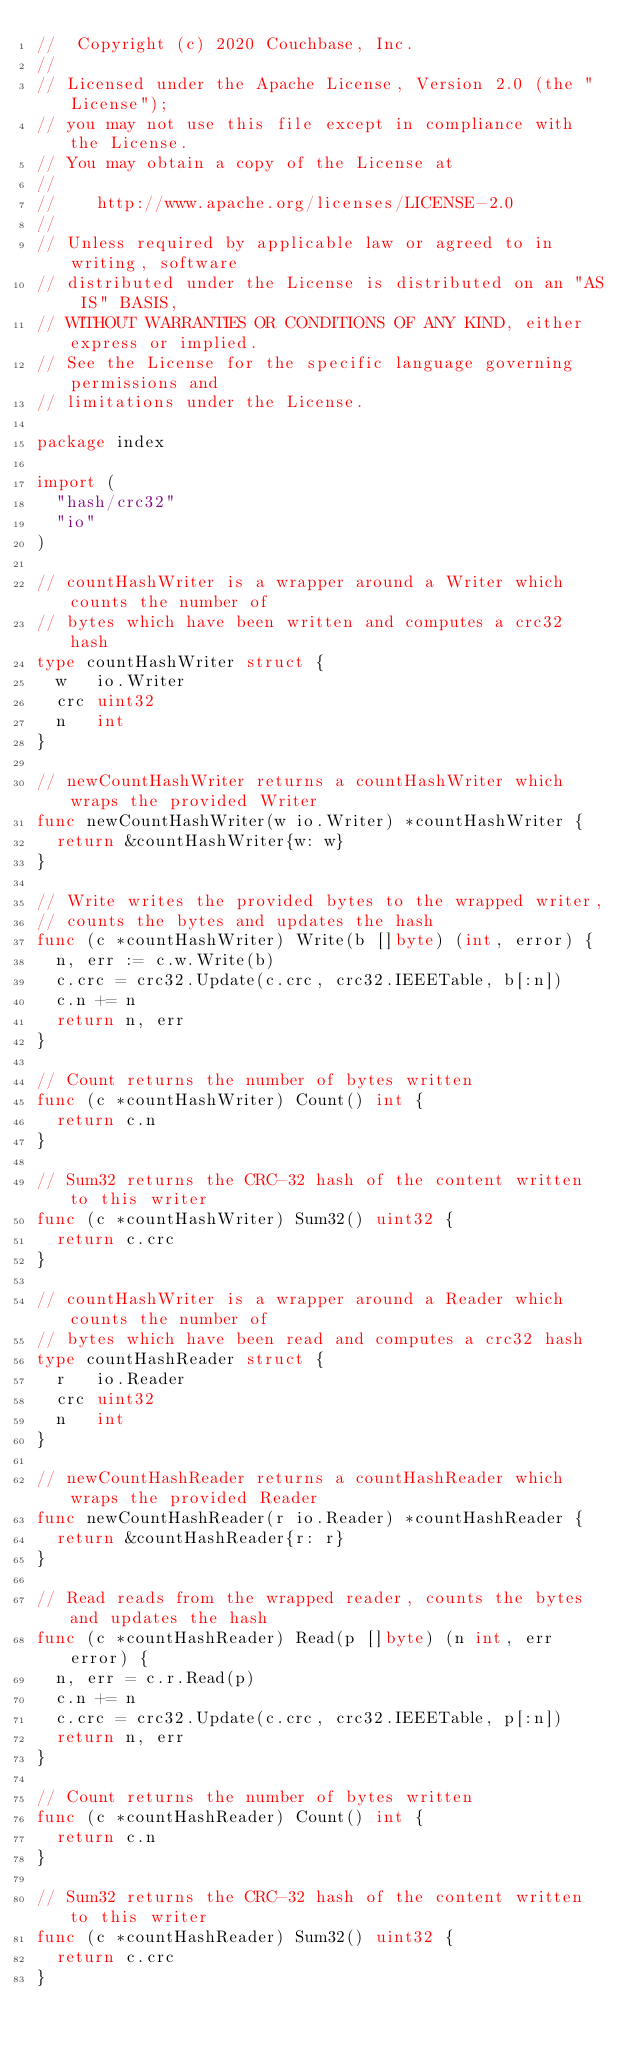<code> <loc_0><loc_0><loc_500><loc_500><_Go_>//  Copyright (c) 2020 Couchbase, Inc.
//
// Licensed under the Apache License, Version 2.0 (the "License");
// you may not use this file except in compliance with the License.
// You may obtain a copy of the License at
//
// 		http://www.apache.org/licenses/LICENSE-2.0
//
// Unless required by applicable law or agreed to in writing, software
// distributed under the License is distributed on an "AS IS" BASIS,
// WITHOUT WARRANTIES OR CONDITIONS OF ANY KIND, either express or implied.
// See the License for the specific language governing permissions and
// limitations under the License.

package index

import (
	"hash/crc32"
	"io"
)

// countHashWriter is a wrapper around a Writer which counts the number of
// bytes which have been written and computes a crc32 hash
type countHashWriter struct {
	w   io.Writer
	crc uint32
	n   int
}

// newCountHashWriter returns a countHashWriter which wraps the provided Writer
func newCountHashWriter(w io.Writer) *countHashWriter {
	return &countHashWriter{w: w}
}

// Write writes the provided bytes to the wrapped writer,
// counts the bytes and updates the hash
func (c *countHashWriter) Write(b []byte) (int, error) {
	n, err := c.w.Write(b)
	c.crc = crc32.Update(c.crc, crc32.IEEETable, b[:n])
	c.n += n
	return n, err
}

// Count returns the number of bytes written
func (c *countHashWriter) Count() int {
	return c.n
}

// Sum32 returns the CRC-32 hash of the content written to this writer
func (c *countHashWriter) Sum32() uint32 {
	return c.crc
}

// countHashWriter is a wrapper around a Reader which counts the number of
// bytes which have been read and computes a crc32 hash
type countHashReader struct {
	r   io.Reader
	crc uint32
	n   int
}

// newCountHashReader returns a countHashReader which wraps the provided Reader
func newCountHashReader(r io.Reader) *countHashReader {
	return &countHashReader{r: r}
}

// Read reads from the wrapped reader, counts the bytes and updates the hash
func (c *countHashReader) Read(p []byte) (n int, err error) {
	n, err = c.r.Read(p)
	c.n += n
	c.crc = crc32.Update(c.crc, crc32.IEEETable, p[:n])
	return n, err
}

// Count returns the number of bytes written
func (c *countHashReader) Count() int {
	return c.n
}

// Sum32 returns the CRC-32 hash of the content written to this writer
func (c *countHashReader) Sum32() uint32 {
	return c.crc
}
</code> 